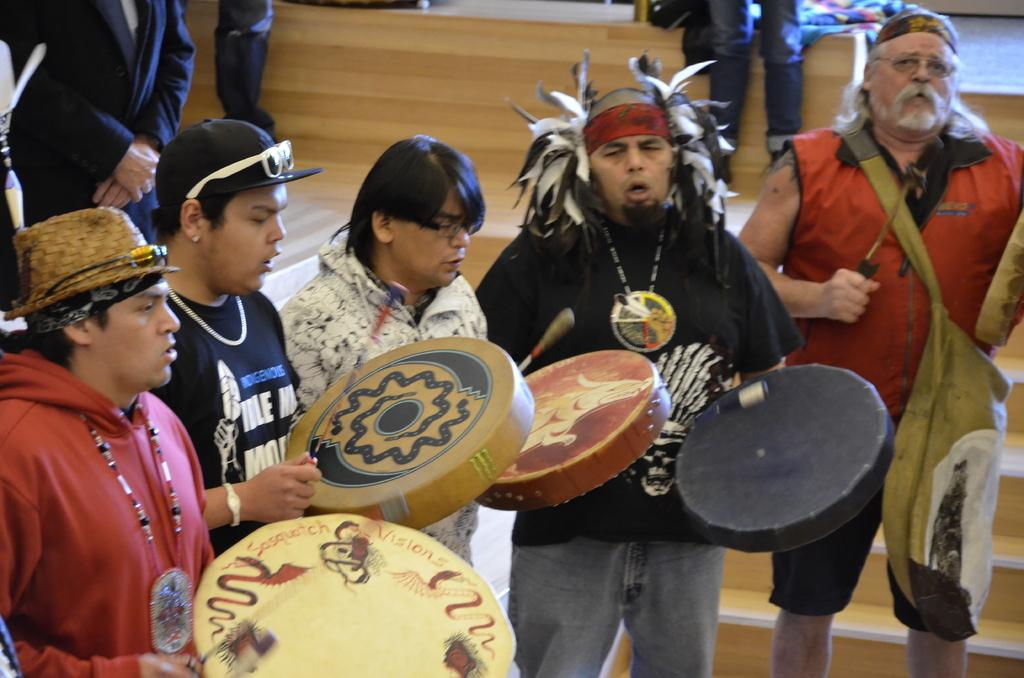How many persons are in the image? There are persons in the image. What are the persons doing in the image? The persons are standing and playing musical instruments. Can you describe the clothing of one of the persons? One person is wearing a hat and a red color jacket. What type of flesh can be seen on the person's face in the image? There is no flesh visible on the person's face in the image; it is not possible to determine the person's skin texture or color from the provided facts. 